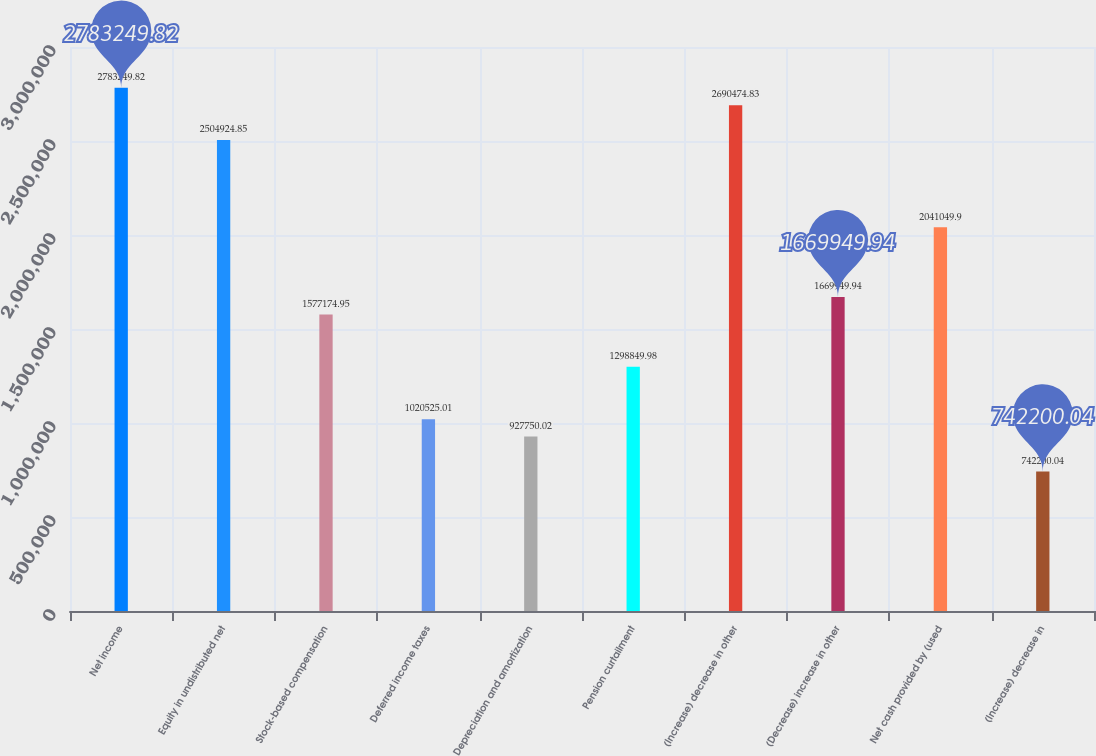Convert chart. <chart><loc_0><loc_0><loc_500><loc_500><bar_chart><fcel>Net income<fcel>Equity in undistributed net<fcel>Stock-based compensation<fcel>Deferred income taxes<fcel>Depreciation and amortization<fcel>Pension curtailment<fcel>(Increase) decrease in other<fcel>(Decrease) increase in other<fcel>Net cash provided by (used<fcel>(Increase) decrease in<nl><fcel>2.78325e+06<fcel>2.50492e+06<fcel>1.57717e+06<fcel>1.02053e+06<fcel>927750<fcel>1.29885e+06<fcel>2.69047e+06<fcel>1.66995e+06<fcel>2.04105e+06<fcel>742200<nl></chart> 